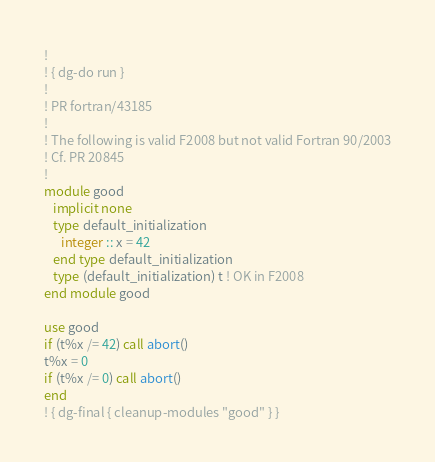<code> <loc_0><loc_0><loc_500><loc_500><_FORTRAN_>!
! { dg-do run }
!
! PR fortran/43185
!
! The following is valid F2008 but not valid Fortran 90/2003
! Cf. PR 20845
!
module good
   implicit none
   type default_initialization
      integer :: x = 42
   end type default_initialization
   type (default_initialization) t ! OK in F2008
end module good

use good
if (t%x /= 42) call abort()
t%x = 0
if (t%x /= 0) call abort()
end
! { dg-final { cleanup-modules "good" } }
</code> 